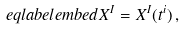<formula> <loc_0><loc_0><loc_500><loc_500>\ e q l a b e l { e m b e d } X ^ { I } = X ^ { I } ( t ^ { i } ) \, ,</formula> 